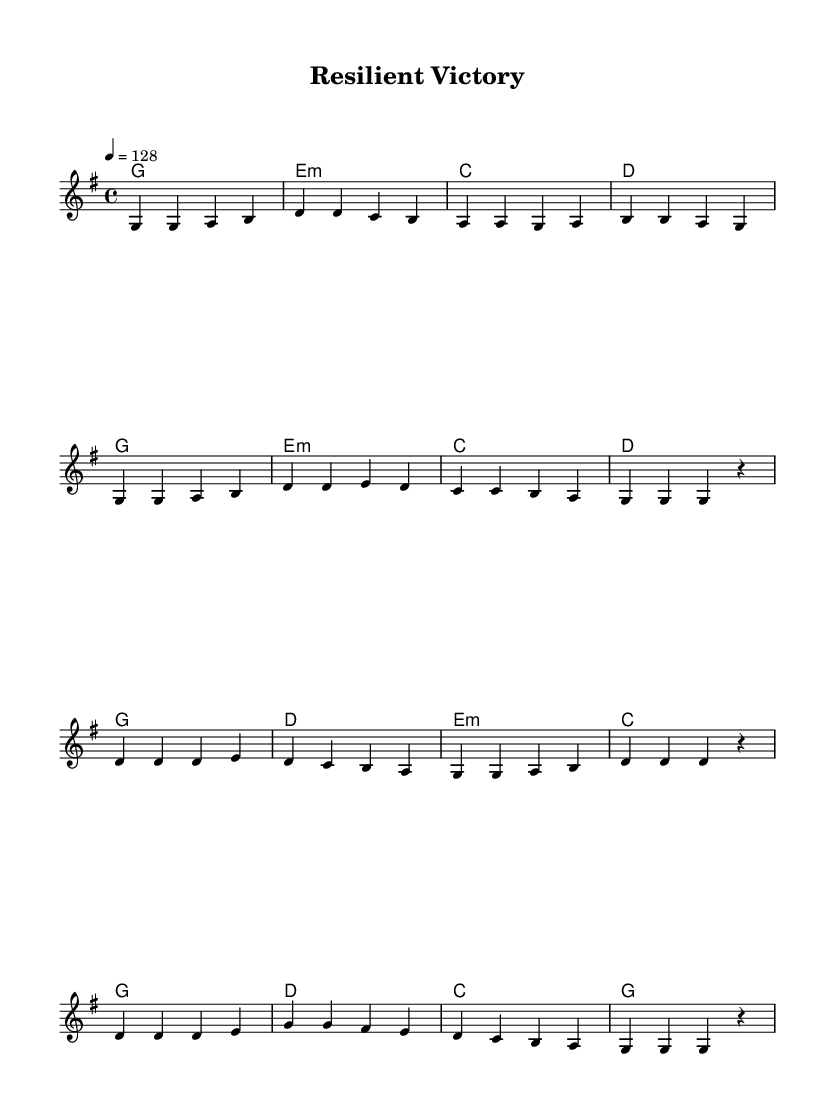What is the key signature of this music? The key signature is G major, which has one sharp (F#). This is indicated at the beginning of the music.
Answer: G major What is the time signature of this music? The time signature is 4/4, which is indicated at the beginning of the piece and specifies four beats per measure.
Answer: 4/4 What is the indicated tempo? The tempo is indicated as 128 beats per minute (notated as 4 = 128), suggesting a moderately fast pace.
Answer: 128 How many measures are in the chorus section? The chorus consists of eight measures, as counted from the beginning of its notation to its end. This is visible in the layout of the sheet music.
Answer: 8 What chord is played in the first measure of the verse? The first measure of the verse features the G major chord, identifiable from the chord symbols written above the staff.
Answer: G Which note is the highest pitch in the melody? The highest pitch in the melody is D, which can be seen in the chorus in the first measure where D is played as the first note.
Answer: D What musical genre does this piece represent? The piece is identified as an upbeat pop song, characterized by a lively tempo and themes of resilience and overcoming challenges, both of which align with pop music’s lyrical and structural qualities.
Answer: Pop 